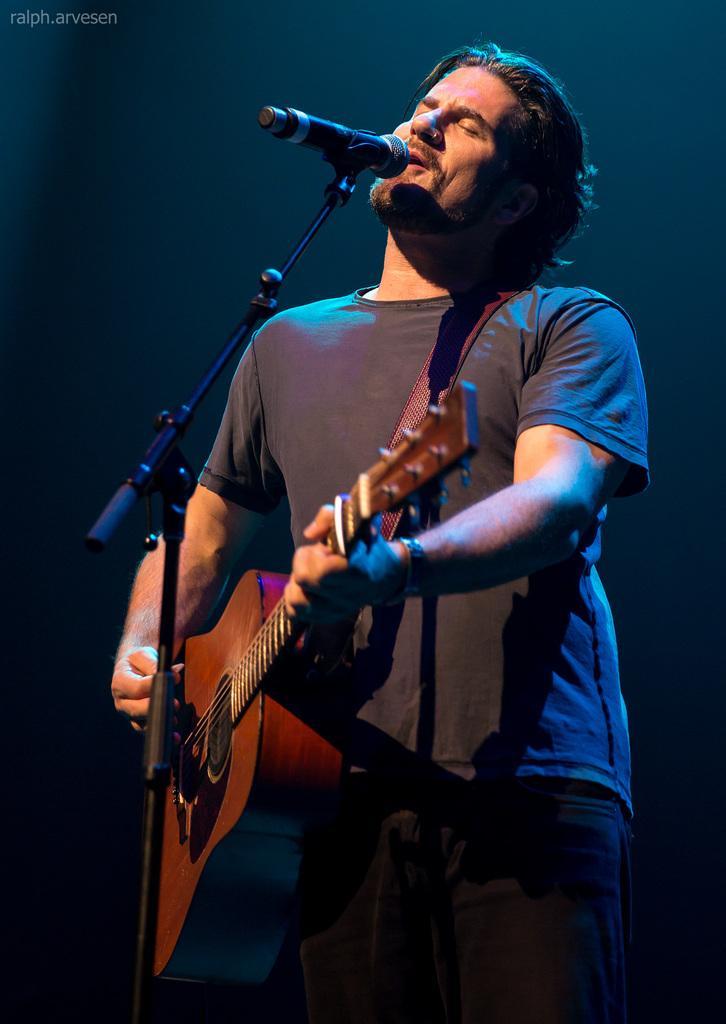Could you give a brief overview of what you see in this image? There is a person with black color t-shirt and with black color pant playing guitar. There is a microphone in front of this person. We can see this person is singing and there's a watch to his right hand. 